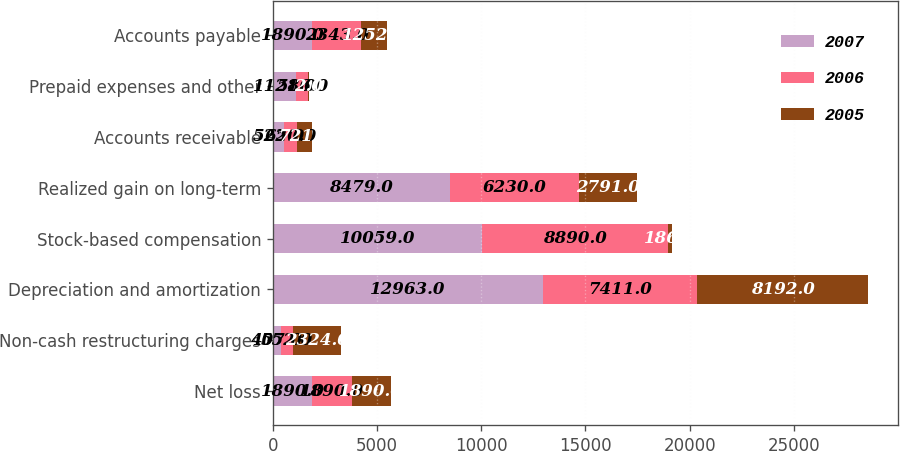<chart> <loc_0><loc_0><loc_500><loc_500><stacked_bar_chart><ecel><fcel>Net loss<fcel>Non-cash restructuring charges<fcel>Depreciation and amortization<fcel>Stock-based compensation<fcel>Realized gain on long-term<fcel>Accounts receivable<fcel>Prepaid expenses and other<fcel>Accounts payable<nl><fcel>2007<fcel>1890<fcel>407<fcel>12963<fcel>10059<fcel>8479<fcel>522<fcel>1121<fcel>1890<nl><fcel>2006<fcel>1890<fcel>552<fcel>7411<fcel>8890<fcel>6230<fcel>650<fcel>586<fcel>2343<nl><fcel>2005<fcel>1890<fcel>2324<fcel>8192<fcel>186<fcel>2791<fcel>721<fcel>2<fcel>1252<nl></chart> 